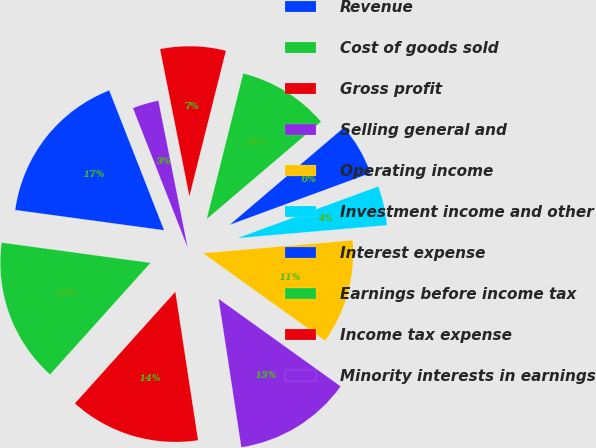Convert chart to OTSL. <chart><loc_0><loc_0><loc_500><loc_500><pie_chart><fcel>Revenue<fcel>Cost of goods sold<fcel>Gross profit<fcel>Selling general and<fcel>Operating income<fcel>Investment income and other<fcel>Interest expense<fcel>Earnings before income tax<fcel>Income tax expense<fcel>Minority interests in earnings<nl><fcel>16.9%<fcel>15.49%<fcel>14.08%<fcel>12.68%<fcel>11.27%<fcel>4.23%<fcel>5.63%<fcel>9.86%<fcel>7.04%<fcel>2.82%<nl></chart> 